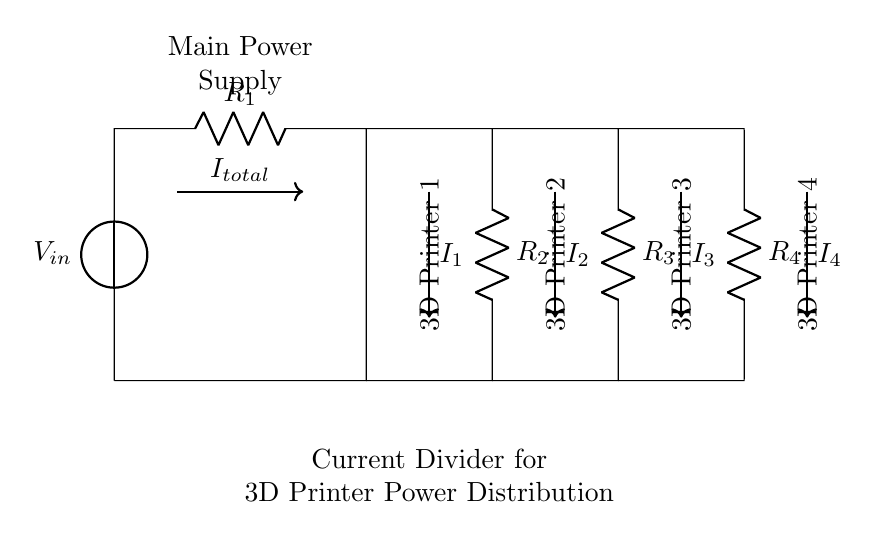What is the input voltage? The input voltage is denoted by \( V_{in} \), which represents the voltage supplied to the circuit.
Answer: \( V_{in} \) How many resistors are in the circuit? There are four resistors represented in the circuit, labeled as \( R_1 \), \( R_2 \), \( R_3 \), and \( R_4 \).
Answer: 4 What is the total current entering the circuit? The total current is denoted by \( I_{total} \), indicated by the arrow going into the power supply and distributing through the resistors.
Answer: \( I_{total} \) What current does 3D Printer 1 receive? 3D Printer 1 is connected directly to \( R_1 \), receiving a current denoted by \( I_1 \), which is part of the current division.
Answer: \( I_1 \) What is the purpose of the current divider in this circuit? The current divider's purpose is to distribute the total current from the main power supply to multiple 3D printers evenly based on the resistance values.
Answer: Distribute current Which component regulates the current to each printer? Each printer's current is regulated by individual resistors \( R_1, R_2, R_3, R_4 \), which dictate the current flow according to Ohm's law.
Answer: Resistors If \( R_2 \) has the highest resistance, which printer gets the least current? Given that current divides inversely with resistance, the printer connected to \( R_2 \) receives the least current due to its highest resistance value.
Answer: Printer 2 